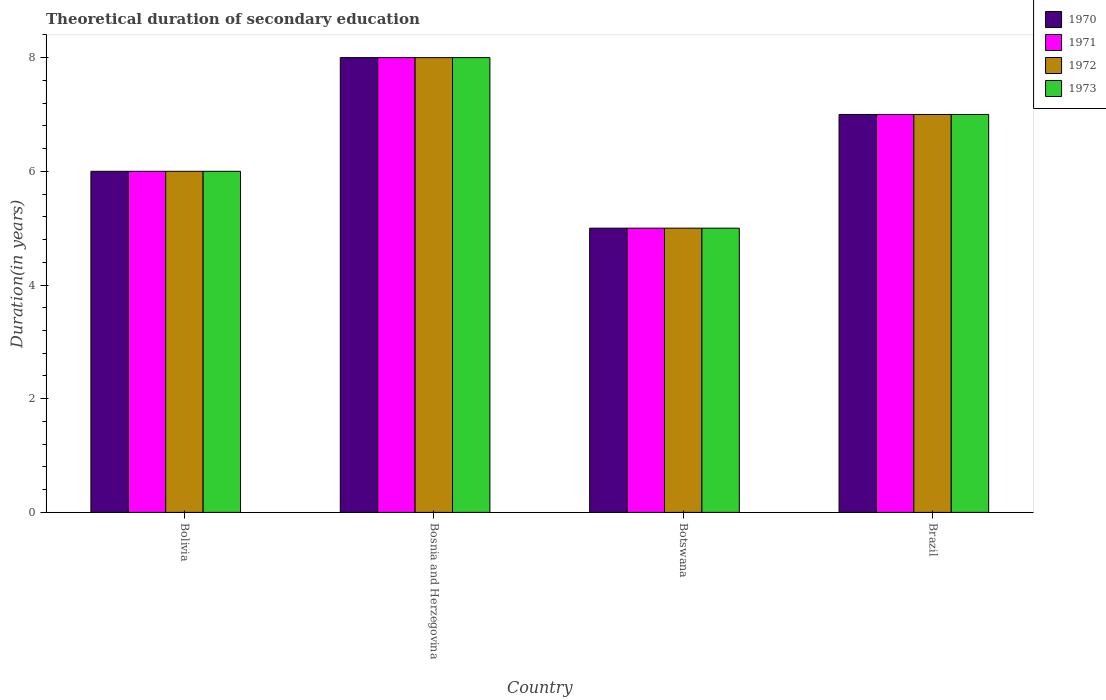How many different coloured bars are there?
Your response must be concise. 4. How many groups of bars are there?
Your answer should be very brief. 4. Are the number of bars on each tick of the X-axis equal?
Provide a short and direct response. Yes. How many bars are there on the 2nd tick from the left?
Keep it short and to the point. 4. What is the label of the 2nd group of bars from the left?
Your response must be concise. Bosnia and Herzegovina. In how many cases, is the number of bars for a given country not equal to the number of legend labels?
Make the answer very short. 0. What is the total theoretical duration of secondary education in 1970 in Bolivia?
Your answer should be very brief. 6. Across all countries, what is the maximum total theoretical duration of secondary education in 1973?
Provide a short and direct response. 8. In which country was the total theoretical duration of secondary education in 1970 maximum?
Give a very brief answer. Bosnia and Herzegovina. In which country was the total theoretical duration of secondary education in 1971 minimum?
Your answer should be compact. Botswana. What is the difference between the total theoretical duration of secondary education in 1972 in Botswana and that in Brazil?
Offer a terse response. -2. What is the average total theoretical duration of secondary education in 1970 per country?
Keep it short and to the point. 6.5. In how many countries, is the total theoretical duration of secondary education in 1972 greater than 3.6 years?
Make the answer very short. 4. Is the total theoretical duration of secondary education in 1970 in Bosnia and Herzegovina less than that in Brazil?
Make the answer very short. No. In how many countries, is the total theoretical duration of secondary education in 1970 greater than the average total theoretical duration of secondary education in 1970 taken over all countries?
Your answer should be compact. 2. Is the sum of the total theoretical duration of secondary education in 1970 in Bolivia and Botswana greater than the maximum total theoretical duration of secondary education in 1972 across all countries?
Your response must be concise. Yes. What does the 4th bar from the left in Brazil represents?
Provide a short and direct response. 1973. What does the 3rd bar from the right in Brazil represents?
Your answer should be very brief. 1971. Is it the case that in every country, the sum of the total theoretical duration of secondary education in 1971 and total theoretical duration of secondary education in 1972 is greater than the total theoretical duration of secondary education in 1970?
Give a very brief answer. Yes. How many bars are there?
Your response must be concise. 16. Are all the bars in the graph horizontal?
Make the answer very short. No. What is the difference between two consecutive major ticks on the Y-axis?
Offer a terse response. 2. Where does the legend appear in the graph?
Provide a succinct answer. Top right. How many legend labels are there?
Ensure brevity in your answer.  4. What is the title of the graph?
Your response must be concise. Theoretical duration of secondary education. Does "1980" appear as one of the legend labels in the graph?
Provide a short and direct response. No. What is the label or title of the Y-axis?
Make the answer very short. Duration(in years). What is the Duration(in years) of 1971 in Bosnia and Herzegovina?
Make the answer very short. 8. What is the Duration(in years) in 1970 in Botswana?
Make the answer very short. 5. What is the Duration(in years) in 1971 in Botswana?
Your answer should be compact. 5. What is the Duration(in years) in 1972 in Botswana?
Offer a terse response. 5. What is the Duration(in years) in 1970 in Brazil?
Keep it short and to the point. 7. What is the Duration(in years) of 1971 in Brazil?
Your answer should be compact. 7. What is the Duration(in years) of 1972 in Brazil?
Make the answer very short. 7. What is the Duration(in years) of 1973 in Brazil?
Ensure brevity in your answer.  7. Across all countries, what is the maximum Duration(in years) in 1971?
Offer a terse response. 8. Across all countries, what is the minimum Duration(in years) of 1970?
Give a very brief answer. 5. Across all countries, what is the minimum Duration(in years) of 1972?
Offer a very short reply. 5. Across all countries, what is the minimum Duration(in years) of 1973?
Your answer should be very brief. 5. What is the total Duration(in years) in 1970 in the graph?
Offer a very short reply. 26. What is the total Duration(in years) in 1971 in the graph?
Your answer should be very brief. 26. What is the difference between the Duration(in years) of 1971 in Bolivia and that in Bosnia and Herzegovina?
Your response must be concise. -2. What is the difference between the Duration(in years) in 1973 in Bolivia and that in Bosnia and Herzegovina?
Provide a short and direct response. -2. What is the difference between the Duration(in years) in 1972 in Bolivia and that in Botswana?
Offer a very short reply. 1. What is the difference between the Duration(in years) in 1973 in Bolivia and that in Botswana?
Keep it short and to the point. 1. What is the difference between the Duration(in years) in 1970 in Bolivia and that in Brazil?
Your answer should be compact. -1. What is the difference between the Duration(in years) in 1971 in Bolivia and that in Brazil?
Ensure brevity in your answer.  -1. What is the difference between the Duration(in years) of 1970 in Bosnia and Herzegovina and that in Botswana?
Provide a short and direct response. 3. What is the difference between the Duration(in years) of 1970 in Bosnia and Herzegovina and that in Brazil?
Give a very brief answer. 1. What is the difference between the Duration(in years) in 1971 in Bosnia and Herzegovina and that in Brazil?
Your response must be concise. 1. What is the difference between the Duration(in years) in 1972 in Bosnia and Herzegovina and that in Brazil?
Offer a terse response. 1. What is the difference between the Duration(in years) in 1973 in Bosnia and Herzegovina and that in Brazil?
Make the answer very short. 1. What is the difference between the Duration(in years) in 1971 in Botswana and that in Brazil?
Your answer should be very brief. -2. What is the difference between the Duration(in years) in 1973 in Botswana and that in Brazil?
Keep it short and to the point. -2. What is the difference between the Duration(in years) of 1970 in Bolivia and the Duration(in years) of 1971 in Bosnia and Herzegovina?
Your answer should be very brief. -2. What is the difference between the Duration(in years) of 1970 in Bolivia and the Duration(in years) of 1972 in Bosnia and Herzegovina?
Your answer should be very brief. -2. What is the difference between the Duration(in years) of 1970 in Bolivia and the Duration(in years) of 1973 in Bosnia and Herzegovina?
Your answer should be compact. -2. What is the difference between the Duration(in years) in 1971 in Bolivia and the Duration(in years) in 1972 in Bosnia and Herzegovina?
Keep it short and to the point. -2. What is the difference between the Duration(in years) in 1972 in Bolivia and the Duration(in years) in 1973 in Bosnia and Herzegovina?
Provide a succinct answer. -2. What is the difference between the Duration(in years) of 1970 in Bolivia and the Duration(in years) of 1971 in Botswana?
Ensure brevity in your answer.  1. What is the difference between the Duration(in years) of 1970 in Bolivia and the Duration(in years) of 1973 in Brazil?
Provide a succinct answer. -1. What is the difference between the Duration(in years) in 1971 in Bolivia and the Duration(in years) in 1973 in Brazil?
Offer a very short reply. -1. What is the difference between the Duration(in years) in 1970 in Bosnia and Herzegovina and the Duration(in years) in 1972 in Botswana?
Your response must be concise. 3. What is the difference between the Duration(in years) in 1970 in Bosnia and Herzegovina and the Duration(in years) in 1973 in Botswana?
Ensure brevity in your answer.  3. What is the difference between the Duration(in years) of 1970 in Bosnia and Herzegovina and the Duration(in years) of 1973 in Brazil?
Your answer should be very brief. 1. What is the difference between the Duration(in years) of 1971 in Bosnia and Herzegovina and the Duration(in years) of 1972 in Brazil?
Your response must be concise. 1. What is the difference between the Duration(in years) in 1972 in Bosnia and Herzegovina and the Duration(in years) in 1973 in Brazil?
Your answer should be compact. 1. What is the difference between the Duration(in years) in 1970 in Botswana and the Duration(in years) in 1971 in Brazil?
Ensure brevity in your answer.  -2. What is the difference between the Duration(in years) in 1971 in Botswana and the Duration(in years) in 1972 in Brazil?
Ensure brevity in your answer.  -2. What is the difference between the Duration(in years) of 1972 in Botswana and the Duration(in years) of 1973 in Brazil?
Provide a succinct answer. -2. What is the average Duration(in years) of 1971 per country?
Offer a very short reply. 6.5. What is the average Duration(in years) in 1973 per country?
Offer a very short reply. 6.5. What is the difference between the Duration(in years) of 1970 and Duration(in years) of 1972 in Bolivia?
Offer a very short reply. 0. What is the difference between the Duration(in years) in 1970 and Duration(in years) in 1973 in Bolivia?
Offer a very short reply. 0. What is the difference between the Duration(in years) in 1971 and Duration(in years) in 1972 in Bolivia?
Your response must be concise. 0. What is the difference between the Duration(in years) of 1972 and Duration(in years) of 1973 in Bolivia?
Make the answer very short. 0. What is the difference between the Duration(in years) of 1970 and Duration(in years) of 1971 in Bosnia and Herzegovina?
Provide a succinct answer. 0. What is the difference between the Duration(in years) in 1970 and Duration(in years) in 1973 in Bosnia and Herzegovina?
Ensure brevity in your answer.  0. What is the difference between the Duration(in years) of 1972 and Duration(in years) of 1973 in Bosnia and Herzegovina?
Make the answer very short. 0. What is the difference between the Duration(in years) in 1970 and Duration(in years) in 1971 in Botswana?
Provide a succinct answer. 0. What is the difference between the Duration(in years) of 1970 and Duration(in years) of 1972 in Botswana?
Offer a very short reply. 0. What is the difference between the Duration(in years) of 1972 and Duration(in years) of 1973 in Botswana?
Your answer should be compact. 0. What is the difference between the Duration(in years) of 1970 and Duration(in years) of 1973 in Brazil?
Give a very brief answer. 0. What is the ratio of the Duration(in years) of 1970 in Bolivia to that in Bosnia and Herzegovina?
Ensure brevity in your answer.  0.75. What is the ratio of the Duration(in years) in 1973 in Bolivia to that in Bosnia and Herzegovina?
Offer a terse response. 0.75. What is the ratio of the Duration(in years) of 1970 in Bolivia to that in Botswana?
Give a very brief answer. 1.2. What is the ratio of the Duration(in years) of 1971 in Bolivia to that in Botswana?
Your answer should be compact. 1.2. What is the ratio of the Duration(in years) in 1970 in Bolivia to that in Brazil?
Make the answer very short. 0.86. What is the ratio of the Duration(in years) of 1972 in Bolivia to that in Brazil?
Provide a succinct answer. 0.86. What is the ratio of the Duration(in years) of 1970 in Bosnia and Herzegovina to that in Brazil?
Your answer should be very brief. 1.14. What is the ratio of the Duration(in years) in 1971 in Botswana to that in Brazil?
Ensure brevity in your answer.  0.71. What is the difference between the highest and the second highest Duration(in years) in 1971?
Keep it short and to the point. 1. What is the difference between the highest and the second highest Duration(in years) of 1972?
Provide a short and direct response. 1. What is the difference between the highest and the lowest Duration(in years) of 1970?
Offer a terse response. 3. 